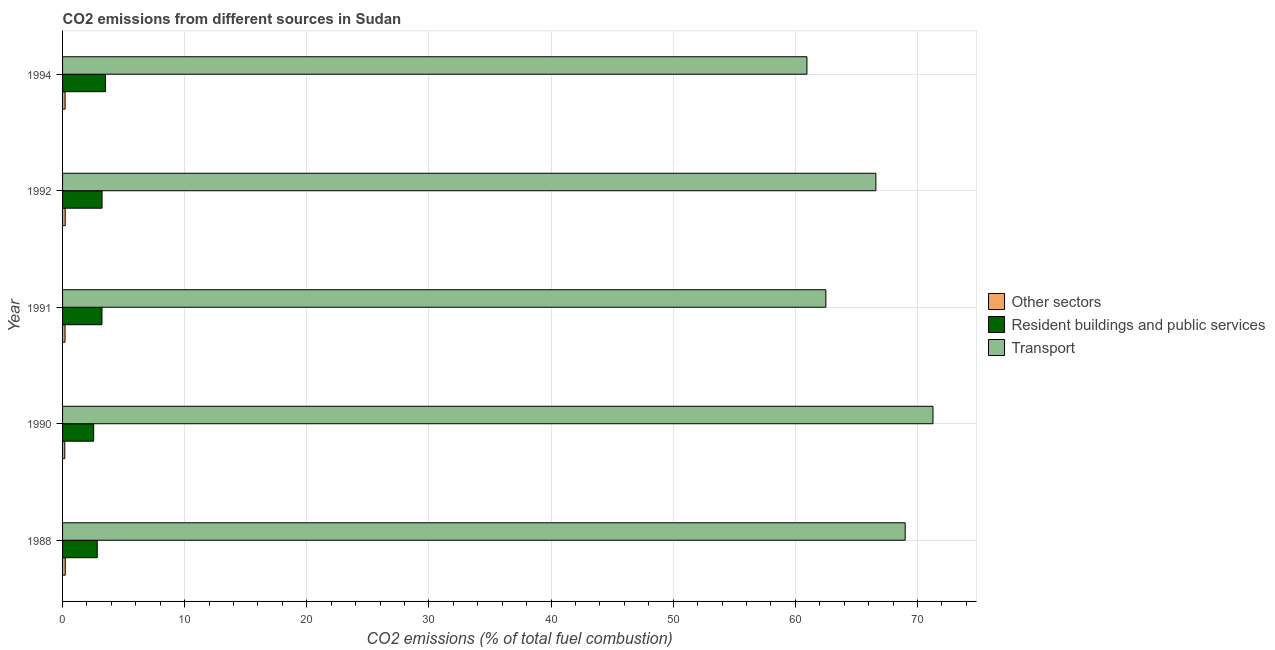How many groups of bars are there?
Your answer should be very brief. 5. Are the number of bars per tick equal to the number of legend labels?
Offer a very short reply. Yes. How many bars are there on the 5th tick from the bottom?
Your response must be concise. 3. What is the label of the 2nd group of bars from the top?
Offer a very short reply. 1992. In how many cases, is the number of bars for a given year not equal to the number of legend labels?
Make the answer very short. 0. What is the percentage of co2 emissions from other sectors in 1994?
Ensure brevity in your answer.  0.21. Across all years, what is the maximum percentage of co2 emissions from resident buildings and public services?
Offer a very short reply. 3.51. Across all years, what is the minimum percentage of co2 emissions from transport?
Offer a terse response. 60.95. In which year was the percentage of co2 emissions from resident buildings and public services minimum?
Provide a short and direct response. 1990. What is the total percentage of co2 emissions from resident buildings and public services in the graph?
Keep it short and to the point. 15.35. What is the difference between the percentage of co2 emissions from transport in 1990 and that in 1991?
Offer a very short reply. 8.77. What is the difference between the percentage of co2 emissions from transport in 1992 and the percentage of co2 emissions from resident buildings and public services in 1991?
Offer a very short reply. 63.37. What is the average percentage of co2 emissions from transport per year?
Your answer should be compact. 66.06. In the year 1988, what is the difference between the percentage of co2 emissions from other sectors and percentage of co2 emissions from resident buildings and public services?
Your answer should be very brief. -2.62. In how many years, is the percentage of co2 emissions from other sectors greater than 60 %?
Offer a terse response. 0. What is the ratio of the percentage of co2 emissions from resident buildings and public services in 1990 to that in 1991?
Your answer should be very brief. 0.79. Is the difference between the percentage of co2 emissions from resident buildings and public services in 1990 and 1992 greater than the difference between the percentage of co2 emissions from transport in 1990 and 1992?
Your answer should be very brief. No. What is the difference between the highest and the second highest percentage of co2 emissions from resident buildings and public services?
Offer a very short reply. 0.28. Is the sum of the percentage of co2 emissions from other sectors in 1988 and 1990 greater than the maximum percentage of co2 emissions from resident buildings and public services across all years?
Offer a terse response. No. What does the 1st bar from the top in 1991 represents?
Keep it short and to the point. Transport. What does the 3rd bar from the bottom in 1991 represents?
Offer a terse response. Transport. How many bars are there?
Your answer should be very brief. 15. Are all the bars in the graph horizontal?
Your response must be concise. Yes. Does the graph contain grids?
Make the answer very short. Yes. What is the title of the graph?
Your response must be concise. CO2 emissions from different sources in Sudan. What is the label or title of the X-axis?
Provide a succinct answer. CO2 emissions (% of total fuel combustion). What is the label or title of the Y-axis?
Your answer should be compact. Year. What is the CO2 emissions (% of total fuel combustion) of Other sectors in 1988?
Make the answer very short. 0.22. What is the CO2 emissions (% of total fuel combustion) of Resident buildings and public services in 1988?
Ensure brevity in your answer.  2.84. What is the CO2 emissions (% of total fuel combustion) in Transport in 1988?
Offer a very short reply. 69. What is the CO2 emissions (% of total fuel combustion) in Other sectors in 1990?
Offer a very short reply. 0.18. What is the CO2 emissions (% of total fuel combustion) of Resident buildings and public services in 1990?
Your answer should be very brief. 2.55. What is the CO2 emissions (% of total fuel combustion) of Transport in 1990?
Your answer should be compact. 71.27. What is the CO2 emissions (% of total fuel combustion) of Other sectors in 1991?
Offer a very short reply. 0.2. What is the CO2 emissions (% of total fuel combustion) in Resident buildings and public services in 1991?
Provide a short and direct response. 3.23. What is the CO2 emissions (% of total fuel combustion) in Transport in 1991?
Provide a succinct answer. 62.5. What is the CO2 emissions (% of total fuel combustion) in Other sectors in 1992?
Provide a succinct answer. 0.22. What is the CO2 emissions (% of total fuel combustion) of Resident buildings and public services in 1992?
Provide a succinct answer. 3.23. What is the CO2 emissions (% of total fuel combustion) of Transport in 1992?
Your response must be concise. 66.59. What is the CO2 emissions (% of total fuel combustion) of Other sectors in 1994?
Give a very brief answer. 0.21. What is the CO2 emissions (% of total fuel combustion) of Resident buildings and public services in 1994?
Your response must be concise. 3.51. What is the CO2 emissions (% of total fuel combustion) in Transport in 1994?
Keep it short and to the point. 60.95. Across all years, what is the maximum CO2 emissions (% of total fuel combustion) of Other sectors?
Keep it short and to the point. 0.22. Across all years, what is the maximum CO2 emissions (% of total fuel combustion) of Resident buildings and public services?
Ensure brevity in your answer.  3.51. Across all years, what is the maximum CO2 emissions (% of total fuel combustion) of Transport?
Keep it short and to the point. 71.27. Across all years, what is the minimum CO2 emissions (% of total fuel combustion) of Other sectors?
Provide a succinct answer. 0.18. Across all years, what is the minimum CO2 emissions (% of total fuel combustion) of Resident buildings and public services?
Give a very brief answer. 2.55. Across all years, what is the minimum CO2 emissions (% of total fuel combustion) in Transport?
Provide a short and direct response. 60.95. What is the total CO2 emissions (% of total fuel combustion) of Other sectors in the graph?
Your answer should be compact. 1.02. What is the total CO2 emissions (% of total fuel combustion) in Resident buildings and public services in the graph?
Keep it short and to the point. 15.35. What is the total CO2 emissions (% of total fuel combustion) of Transport in the graph?
Offer a terse response. 330.31. What is the difference between the CO2 emissions (% of total fuel combustion) of Other sectors in 1988 and that in 1990?
Keep it short and to the point. 0.04. What is the difference between the CO2 emissions (% of total fuel combustion) in Resident buildings and public services in 1988 and that in 1990?
Offer a very short reply. 0.29. What is the difference between the CO2 emissions (% of total fuel combustion) in Transport in 1988 and that in 1990?
Ensure brevity in your answer.  -2.28. What is the difference between the CO2 emissions (% of total fuel combustion) of Other sectors in 1988 and that in 1991?
Your answer should be compact. 0.02. What is the difference between the CO2 emissions (% of total fuel combustion) of Resident buildings and public services in 1988 and that in 1991?
Provide a succinct answer. -0.39. What is the difference between the CO2 emissions (% of total fuel combustion) of Transport in 1988 and that in 1991?
Your answer should be very brief. 6.5. What is the difference between the CO2 emissions (% of total fuel combustion) of Other sectors in 1988 and that in 1992?
Your response must be concise. 0. What is the difference between the CO2 emissions (% of total fuel combustion) of Resident buildings and public services in 1988 and that in 1992?
Make the answer very short. -0.39. What is the difference between the CO2 emissions (% of total fuel combustion) of Transport in 1988 and that in 1992?
Your response must be concise. 2.4. What is the difference between the CO2 emissions (% of total fuel combustion) in Other sectors in 1988 and that in 1994?
Your response must be concise. 0.01. What is the difference between the CO2 emissions (% of total fuel combustion) of Resident buildings and public services in 1988 and that in 1994?
Offer a terse response. -0.67. What is the difference between the CO2 emissions (% of total fuel combustion) in Transport in 1988 and that in 1994?
Provide a succinct answer. 8.05. What is the difference between the CO2 emissions (% of total fuel combustion) in Other sectors in 1990 and that in 1991?
Provide a succinct answer. -0.02. What is the difference between the CO2 emissions (% of total fuel combustion) of Resident buildings and public services in 1990 and that in 1991?
Give a very brief answer. -0.68. What is the difference between the CO2 emissions (% of total fuel combustion) in Transport in 1990 and that in 1991?
Keep it short and to the point. 8.77. What is the difference between the CO2 emissions (% of total fuel combustion) of Other sectors in 1990 and that in 1992?
Your answer should be very brief. -0.03. What is the difference between the CO2 emissions (% of total fuel combustion) of Resident buildings and public services in 1990 and that in 1992?
Your answer should be compact. -0.69. What is the difference between the CO2 emissions (% of total fuel combustion) in Transport in 1990 and that in 1992?
Your answer should be compact. 4.68. What is the difference between the CO2 emissions (% of total fuel combustion) of Other sectors in 1990 and that in 1994?
Provide a succinct answer. -0.02. What is the difference between the CO2 emissions (% of total fuel combustion) of Resident buildings and public services in 1990 and that in 1994?
Give a very brief answer. -0.97. What is the difference between the CO2 emissions (% of total fuel combustion) of Transport in 1990 and that in 1994?
Give a very brief answer. 10.32. What is the difference between the CO2 emissions (% of total fuel combustion) in Other sectors in 1991 and that in 1992?
Your answer should be very brief. -0.01. What is the difference between the CO2 emissions (% of total fuel combustion) in Resident buildings and public services in 1991 and that in 1992?
Offer a terse response. -0.01. What is the difference between the CO2 emissions (% of total fuel combustion) of Transport in 1991 and that in 1992?
Your response must be concise. -4.09. What is the difference between the CO2 emissions (% of total fuel combustion) of Other sectors in 1991 and that in 1994?
Make the answer very short. -0.01. What is the difference between the CO2 emissions (% of total fuel combustion) in Resident buildings and public services in 1991 and that in 1994?
Give a very brief answer. -0.29. What is the difference between the CO2 emissions (% of total fuel combustion) in Transport in 1991 and that in 1994?
Your response must be concise. 1.55. What is the difference between the CO2 emissions (% of total fuel combustion) of Other sectors in 1992 and that in 1994?
Keep it short and to the point. 0.01. What is the difference between the CO2 emissions (% of total fuel combustion) in Resident buildings and public services in 1992 and that in 1994?
Provide a short and direct response. -0.28. What is the difference between the CO2 emissions (% of total fuel combustion) of Transport in 1992 and that in 1994?
Your response must be concise. 5.64. What is the difference between the CO2 emissions (% of total fuel combustion) of Other sectors in 1988 and the CO2 emissions (% of total fuel combustion) of Resident buildings and public services in 1990?
Make the answer very short. -2.33. What is the difference between the CO2 emissions (% of total fuel combustion) of Other sectors in 1988 and the CO2 emissions (% of total fuel combustion) of Transport in 1990?
Your answer should be very brief. -71.05. What is the difference between the CO2 emissions (% of total fuel combustion) of Resident buildings and public services in 1988 and the CO2 emissions (% of total fuel combustion) of Transport in 1990?
Provide a short and direct response. -68.43. What is the difference between the CO2 emissions (% of total fuel combustion) of Other sectors in 1988 and the CO2 emissions (% of total fuel combustion) of Resident buildings and public services in 1991?
Keep it short and to the point. -3.01. What is the difference between the CO2 emissions (% of total fuel combustion) in Other sectors in 1988 and the CO2 emissions (% of total fuel combustion) in Transport in 1991?
Provide a short and direct response. -62.28. What is the difference between the CO2 emissions (% of total fuel combustion) in Resident buildings and public services in 1988 and the CO2 emissions (% of total fuel combustion) in Transport in 1991?
Offer a very short reply. -59.66. What is the difference between the CO2 emissions (% of total fuel combustion) in Other sectors in 1988 and the CO2 emissions (% of total fuel combustion) in Resident buildings and public services in 1992?
Make the answer very short. -3.01. What is the difference between the CO2 emissions (% of total fuel combustion) of Other sectors in 1988 and the CO2 emissions (% of total fuel combustion) of Transport in 1992?
Give a very brief answer. -66.38. What is the difference between the CO2 emissions (% of total fuel combustion) of Resident buildings and public services in 1988 and the CO2 emissions (% of total fuel combustion) of Transport in 1992?
Provide a short and direct response. -63.76. What is the difference between the CO2 emissions (% of total fuel combustion) in Other sectors in 1988 and the CO2 emissions (% of total fuel combustion) in Resident buildings and public services in 1994?
Your answer should be compact. -3.29. What is the difference between the CO2 emissions (% of total fuel combustion) in Other sectors in 1988 and the CO2 emissions (% of total fuel combustion) in Transport in 1994?
Keep it short and to the point. -60.73. What is the difference between the CO2 emissions (% of total fuel combustion) in Resident buildings and public services in 1988 and the CO2 emissions (% of total fuel combustion) in Transport in 1994?
Offer a very short reply. -58.11. What is the difference between the CO2 emissions (% of total fuel combustion) in Other sectors in 1990 and the CO2 emissions (% of total fuel combustion) in Resident buildings and public services in 1991?
Your answer should be very brief. -3.04. What is the difference between the CO2 emissions (% of total fuel combustion) in Other sectors in 1990 and the CO2 emissions (% of total fuel combustion) in Transport in 1991?
Provide a succinct answer. -62.32. What is the difference between the CO2 emissions (% of total fuel combustion) in Resident buildings and public services in 1990 and the CO2 emissions (% of total fuel combustion) in Transport in 1991?
Keep it short and to the point. -59.95. What is the difference between the CO2 emissions (% of total fuel combustion) of Other sectors in 1990 and the CO2 emissions (% of total fuel combustion) of Resident buildings and public services in 1992?
Provide a succinct answer. -3.05. What is the difference between the CO2 emissions (% of total fuel combustion) in Other sectors in 1990 and the CO2 emissions (% of total fuel combustion) in Transport in 1992?
Keep it short and to the point. -66.41. What is the difference between the CO2 emissions (% of total fuel combustion) of Resident buildings and public services in 1990 and the CO2 emissions (% of total fuel combustion) of Transport in 1992?
Your answer should be very brief. -64.05. What is the difference between the CO2 emissions (% of total fuel combustion) in Other sectors in 1990 and the CO2 emissions (% of total fuel combustion) in Resident buildings and public services in 1994?
Offer a very short reply. -3.33. What is the difference between the CO2 emissions (% of total fuel combustion) in Other sectors in 1990 and the CO2 emissions (% of total fuel combustion) in Transport in 1994?
Provide a short and direct response. -60.77. What is the difference between the CO2 emissions (% of total fuel combustion) in Resident buildings and public services in 1990 and the CO2 emissions (% of total fuel combustion) in Transport in 1994?
Your answer should be compact. -58.41. What is the difference between the CO2 emissions (% of total fuel combustion) of Other sectors in 1991 and the CO2 emissions (% of total fuel combustion) of Resident buildings and public services in 1992?
Your answer should be very brief. -3.03. What is the difference between the CO2 emissions (% of total fuel combustion) of Other sectors in 1991 and the CO2 emissions (% of total fuel combustion) of Transport in 1992?
Your answer should be very brief. -66.39. What is the difference between the CO2 emissions (% of total fuel combustion) in Resident buildings and public services in 1991 and the CO2 emissions (% of total fuel combustion) in Transport in 1992?
Ensure brevity in your answer.  -63.37. What is the difference between the CO2 emissions (% of total fuel combustion) of Other sectors in 1991 and the CO2 emissions (% of total fuel combustion) of Resident buildings and public services in 1994?
Provide a short and direct response. -3.31. What is the difference between the CO2 emissions (% of total fuel combustion) of Other sectors in 1991 and the CO2 emissions (% of total fuel combustion) of Transport in 1994?
Provide a succinct answer. -60.75. What is the difference between the CO2 emissions (% of total fuel combustion) of Resident buildings and public services in 1991 and the CO2 emissions (% of total fuel combustion) of Transport in 1994?
Provide a succinct answer. -57.72. What is the difference between the CO2 emissions (% of total fuel combustion) in Other sectors in 1992 and the CO2 emissions (% of total fuel combustion) in Resident buildings and public services in 1994?
Make the answer very short. -3.3. What is the difference between the CO2 emissions (% of total fuel combustion) in Other sectors in 1992 and the CO2 emissions (% of total fuel combustion) in Transport in 1994?
Your answer should be compact. -60.73. What is the difference between the CO2 emissions (% of total fuel combustion) of Resident buildings and public services in 1992 and the CO2 emissions (% of total fuel combustion) of Transport in 1994?
Your answer should be compact. -57.72. What is the average CO2 emissions (% of total fuel combustion) in Other sectors per year?
Provide a succinct answer. 0.2. What is the average CO2 emissions (% of total fuel combustion) in Resident buildings and public services per year?
Offer a terse response. 3.07. What is the average CO2 emissions (% of total fuel combustion) in Transport per year?
Make the answer very short. 66.06. In the year 1988, what is the difference between the CO2 emissions (% of total fuel combustion) in Other sectors and CO2 emissions (% of total fuel combustion) in Resident buildings and public services?
Your answer should be compact. -2.62. In the year 1988, what is the difference between the CO2 emissions (% of total fuel combustion) of Other sectors and CO2 emissions (% of total fuel combustion) of Transport?
Offer a terse response. -68.78. In the year 1988, what is the difference between the CO2 emissions (% of total fuel combustion) in Resident buildings and public services and CO2 emissions (% of total fuel combustion) in Transport?
Your answer should be compact. -66.16. In the year 1990, what is the difference between the CO2 emissions (% of total fuel combustion) of Other sectors and CO2 emissions (% of total fuel combustion) of Resident buildings and public services?
Keep it short and to the point. -2.36. In the year 1990, what is the difference between the CO2 emissions (% of total fuel combustion) in Other sectors and CO2 emissions (% of total fuel combustion) in Transport?
Give a very brief answer. -71.09. In the year 1990, what is the difference between the CO2 emissions (% of total fuel combustion) of Resident buildings and public services and CO2 emissions (% of total fuel combustion) of Transport?
Ensure brevity in your answer.  -68.73. In the year 1991, what is the difference between the CO2 emissions (% of total fuel combustion) of Other sectors and CO2 emissions (% of total fuel combustion) of Resident buildings and public services?
Your answer should be very brief. -3.02. In the year 1991, what is the difference between the CO2 emissions (% of total fuel combustion) of Other sectors and CO2 emissions (% of total fuel combustion) of Transport?
Offer a terse response. -62.3. In the year 1991, what is the difference between the CO2 emissions (% of total fuel combustion) of Resident buildings and public services and CO2 emissions (% of total fuel combustion) of Transport?
Keep it short and to the point. -59.27. In the year 1992, what is the difference between the CO2 emissions (% of total fuel combustion) in Other sectors and CO2 emissions (% of total fuel combustion) in Resident buildings and public services?
Your answer should be compact. -3.02. In the year 1992, what is the difference between the CO2 emissions (% of total fuel combustion) of Other sectors and CO2 emissions (% of total fuel combustion) of Transport?
Make the answer very short. -66.38. In the year 1992, what is the difference between the CO2 emissions (% of total fuel combustion) of Resident buildings and public services and CO2 emissions (% of total fuel combustion) of Transport?
Ensure brevity in your answer.  -63.36. In the year 1994, what is the difference between the CO2 emissions (% of total fuel combustion) of Other sectors and CO2 emissions (% of total fuel combustion) of Resident buildings and public services?
Offer a terse response. -3.31. In the year 1994, what is the difference between the CO2 emissions (% of total fuel combustion) of Other sectors and CO2 emissions (% of total fuel combustion) of Transport?
Provide a short and direct response. -60.74. In the year 1994, what is the difference between the CO2 emissions (% of total fuel combustion) in Resident buildings and public services and CO2 emissions (% of total fuel combustion) in Transport?
Offer a very short reply. -57.44. What is the ratio of the CO2 emissions (% of total fuel combustion) of Other sectors in 1988 to that in 1990?
Offer a terse response. 1.2. What is the ratio of the CO2 emissions (% of total fuel combustion) in Resident buildings and public services in 1988 to that in 1990?
Keep it short and to the point. 1.12. What is the ratio of the CO2 emissions (% of total fuel combustion) in Transport in 1988 to that in 1990?
Ensure brevity in your answer.  0.97. What is the ratio of the CO2 emissions (% of total fuel combustion) of Other sectors in 1988 to that in 1991?
Your answer should be compact. 1.08. What is the ratio of the CO2 emissions (% of total fuel combustion) of Resident buildings and public services in 1988 to that in 1991?
Offer a very short reply. 0.88. What is the ratio of the CO2 emissions (% of total fuel combustion) in Transport in 1988 to that in 1991?
Ensure brevity in your answer.  1.1. What is the ratio of the CO2 emissions (% of total fuel combustion) of Other sectors in 1988 to that in 1992?
Give a very brief answer. 1.01. What is the ratio of the CO2 emissions (% of total fuel combustion) in Resident buildings and public services in 1988 to that in 1992?
Keep it short and to the point. 0.88. What is the ratio of the CO2 emissions (% of total fuel combustion) in Transport in 1988 to that in 1992?
Your answer should be compact. 1.04. What is the ratio of the CO2 emissions (% of total fuel combustion) in Other sectors in 1988 to that in 1994?
Provide a succinct answer. 1.06. What is the ratio of the CO2 emissions (% of total fuel combustion) in Resident buildings and public services in 1988 to that in 1994?
Ensure brevity in your answer.  0.81. What is the ratio of the CO2 emissions (% of total fuel combustion) in Transport in 1988 to that in 1994?
Your answer should be very brief. 1.13. What is the ratio of the CO2 emissions (% of total fuel combustion) in Other sectors in 1990 to that in 1991?
Your answer should be compact. 0.9. What is the ratio of the CO2 emissions (% of total fuel combustion) of Resident buildings and public services in 1990 to that in 1991?
Your answer should be compact. 0.79. What is the ratio of the CO2 emissions (% of total fuel combustion) of Transport in 1990 to that in 1991?
Ensure brevity in your answer.  1.14. What is the ratio of the CO2 emissions (% of total fuel combustion) in Other sectors in 1990 to that in 1992?
Provide a short and direct response. 0.84. What is the ratio of the CO2 emissions (% of total fuel combustion) of Resident buildings and public services in 1990 to that in 1992?
Keep it short and to the point. 0.79. What is the ratio of the CO2 emissions (% of total fuel combustion) in Transport in 1990 to that in 1992?
Make the answer very short. 1.07. What is the ratio of the CO2 emissions (% of total fuel combustion) of Resident buildings and public services in 1990 to that in 1994?
Provide a short and direct response. 0.72. What is the ratio of the CO2 emissions (% of total fuel combustion) in Transport in 1990 to that in 1994?
Your answer should be very brief. 1.17. What is the ratio of the CO2 emissions (% of total fuel combustion) of Other sectors in 1991 to that in 1992?
Your response must be concise. 0.94. What is the ratio of the CO2 emissions (% of total fuel combustion) in Transport in 1991 to that in 1992?
Make the answer very short. 0.94. What is the ratio of the CO2 emissions (% of total fuel combustion) in Other sectors in 1991 to that in 1994?
Your answer should be compact. 0.98. What is the ratio of the CO2 emissions (% of total fuel combustion) in Resident buildings and public services in 1991 to that in 1994?
Give a very brief answer. 0.92. What is the ratio of the CO2 emissions (% of total fuel combustion) of Transport in 1991 to that in 1994?
Provide a succinct answer. 1.03. What is the ratio of the CO2 emissions (% of total fuel combustion) in Other sectors in 1992 to that in 1994?
Offer a terse response. 1.04. What is the ratio of the CO2 emissions (% of total fuel combustion) in Resident buildings and public services in 1992 to that in 1994?
Provide a short and direct response. 0.92. What is the ratio of the CO2 emissions (% of total fuel combustion) in Transport in 1992 to that in 1994?
Make the answer very short. 1.09. What is the difference between the highest and the second highest CO2 emissions (% of total fuel combustion) of Other sectors?
Ensure brevity in your answer.  0. What is the difference between the highest and the second highest CO2 emissions (% of total fuel combustion) in Resident buildings and public services?
Your answer should be compact. 0.28. What is the difference between the highest and the second highest CO2 emissions (% of total fuel combustion) in Transport?
Make the answer very short. 2.28. What is the difference between the highest and the lowest CO2 emissions (% of total fuel combustion) of Other sectors?
Your answer should be very brief. 0.04. What is the difference between the highest and the lowest CO2 emissions (% of total fuel combustion) of Resident buildings and public services?
Your response must be concise. 0.97. What is the difference between the highest and the lowest CO2 emissions (% of total fuel combustion) in Transport?
Offer a terse response. 10.32. 